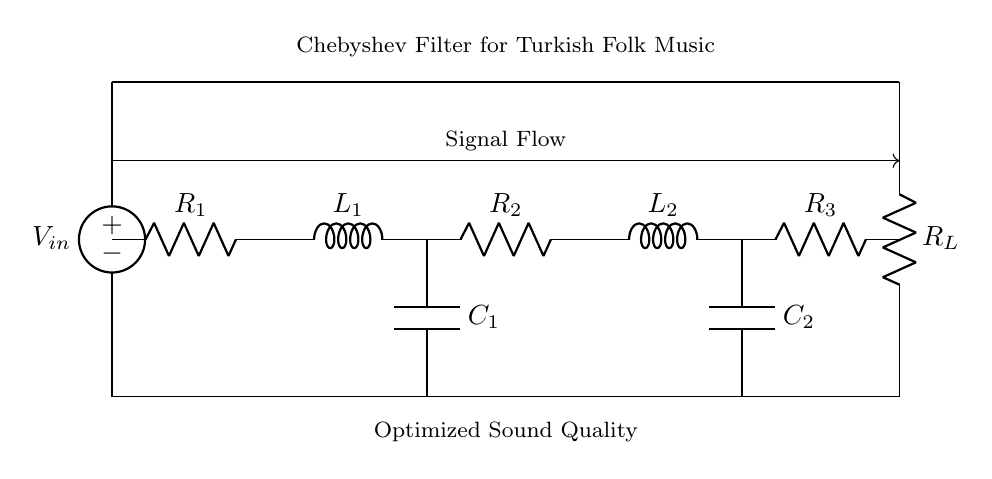What is the type of this circuit? The circuit is a Chebyshev filter, which is indicated in the label at the top of the diagram.
Answer: Chebyshev filter How many resistors are in the circuit? There are three resistors (R1, R2, R3) clearly marked in the circuit diagram.
Answer: 3 What does the voltage source represent? The voltage source, labeled as V_in, represents the input voltage supplied to the circuit for processing.
Answer: Input voltage Which component is connected to the load resistance? The load resistance, labeled R_L, is connected directly to output from the last resistor (R3) on the right side of the circuit.
Answer: R_L What type of components are used in this filter? The components used in this filter include resistors, inductors, and capacitors, as seen through the labels R, L, and C in the circuit diagram.
Answer: Resistors, inductors, and capacitors What is the purpose of this filter? This Chebyshev filter is specifically designed for optimizing sound quality in Turkish folk music playback systems, as indicated by the labeling.
Answer: Optimize sound quality How is the signal flow represented in the diagram? The signal flow is represented by the arrow shown above the circuit diagram, indicating the direction in which the audio signal travels through the components.
Answer: Arrow indicating signal flow 